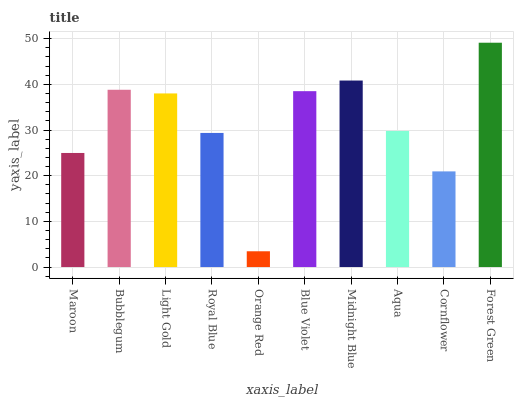Is Orange Red the minimum?
Answer yes or no. Yes. Is Forest Green the maximum?
Answer yes or no. Yes. Is Bubblegum the minimum?
Answer yes or no. No. Is Bubblegum the maximum?
Answer yes or no. No. Is Bubblegum greater than Maroon?
Answer yes or no. Yes. Is Maroon less than Bubblegum?
Answer yes or no. Yes. Is Maroon greater than Bubblegum?
Answer yes or no. No. Is Bubblegum less than Maroon?
Answer yes or no. No. Is Light Gold the high median?
Answer yes or no. Yes. Is Aqua the low median?
Answer yes or no. Yes. Is Royal Blue the high median?
Answer yes or no. No. Is Orange Red the low median?
Answer yes or no. No. 